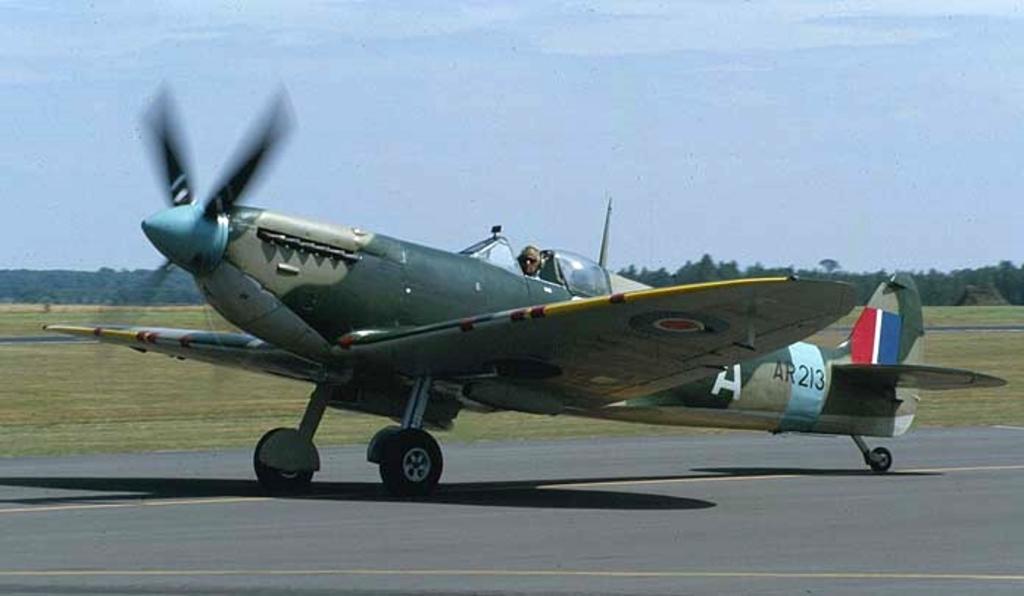What is the airplane number?
Offer a terse response. 213. 